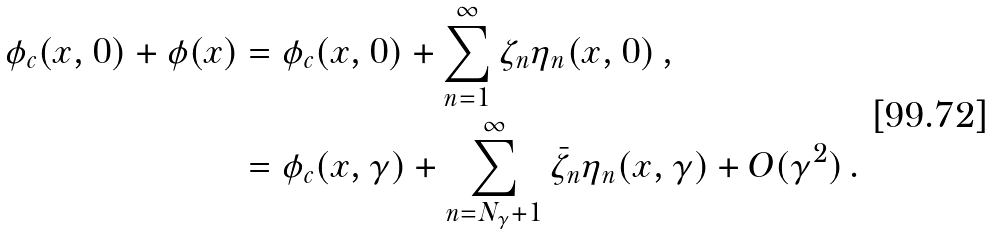Convert formula to latex. <formula><loc_0><loc_0><loc_500><loc_500>\phi _ { c } ( x , 0 ) + \phi ( x ) & = \phi _ { c } ( x , 0 ) + \sum _ { n = 1 } ^ { \infty } \zeta _ { n } \eta _ { n } ( x , 0 ) \, , \\ & = \phi _ { c } ( x , \gamma ) + \sum _ { n = N _ { \gamma } + 1 } ^ { \infty } \bar { \zeta } _ { n } \eta _ { n } ( x , \gamma ) + O ( \gamma ^ { 2 } ) \, .</formula> 